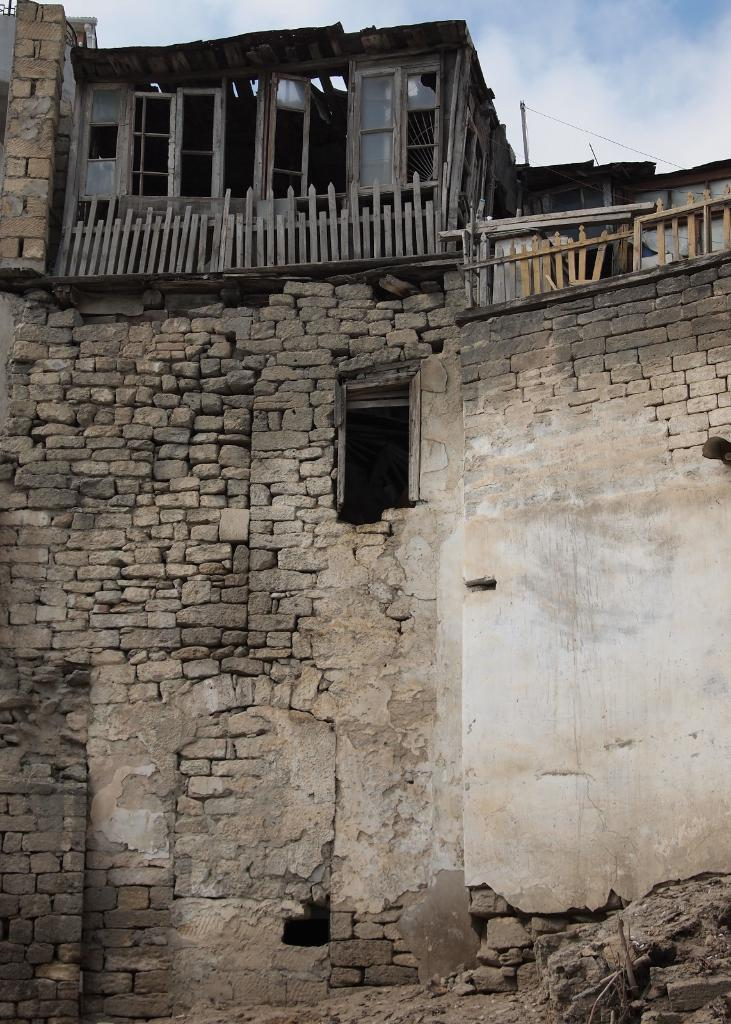What can be seen in the background of the image? The sky is visible in the image. What type of structure is present in the image? There is a building in the image. What kind of barrier is featured in the image? There is a wooden fence in the image. What allows light to enter the building in the image? Windows are present in the image. Can you see a guitar being played by a pet wearing a coat in the image? No, there is no guitar, pet, or coat present in the image. 